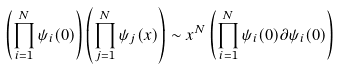Convert formula to latex. <formula><loc_0><loc_0><loc_500><loc_500>\left ( \prod _ { i = 1 } ^ { N } \psi _ { i } ( 0 ) \right ) \left ( \prod _ { j = 1 } ^ { N } \psi _ { j } ( x ) \right ) \sim x ^ { N } \left ( \prod _ { i = 1 } ^ { N } \psi _ { i } ( 0 ) \partial \psi _ { i } ( 0 ) \right )</formula> 